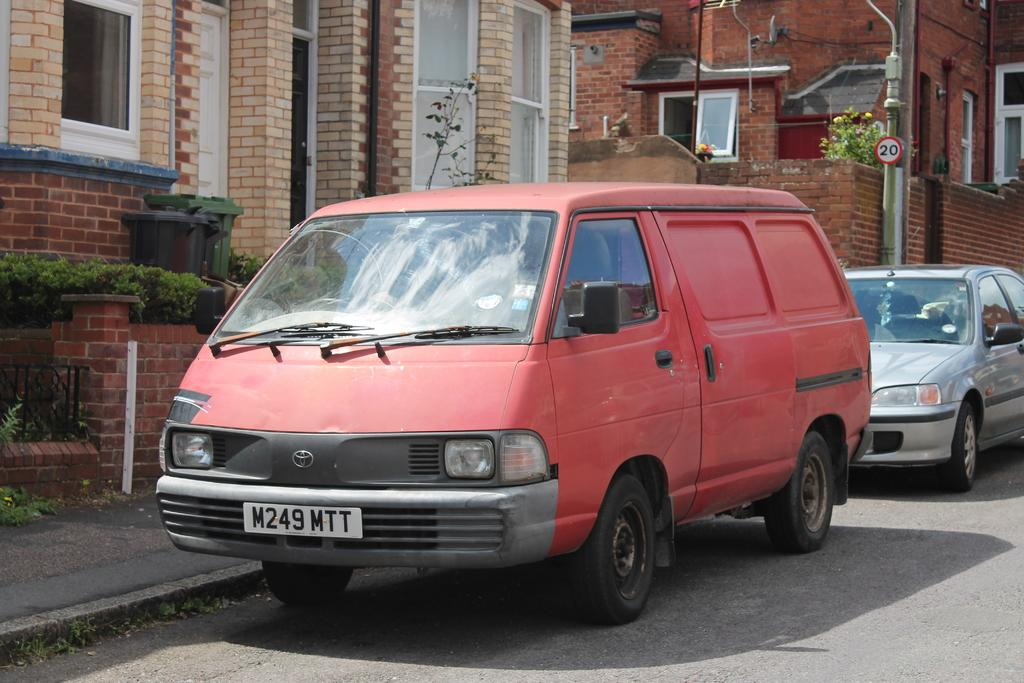<image>
Create a compact narrative representing the image presented. The tag number of the red van is M249MTT. 